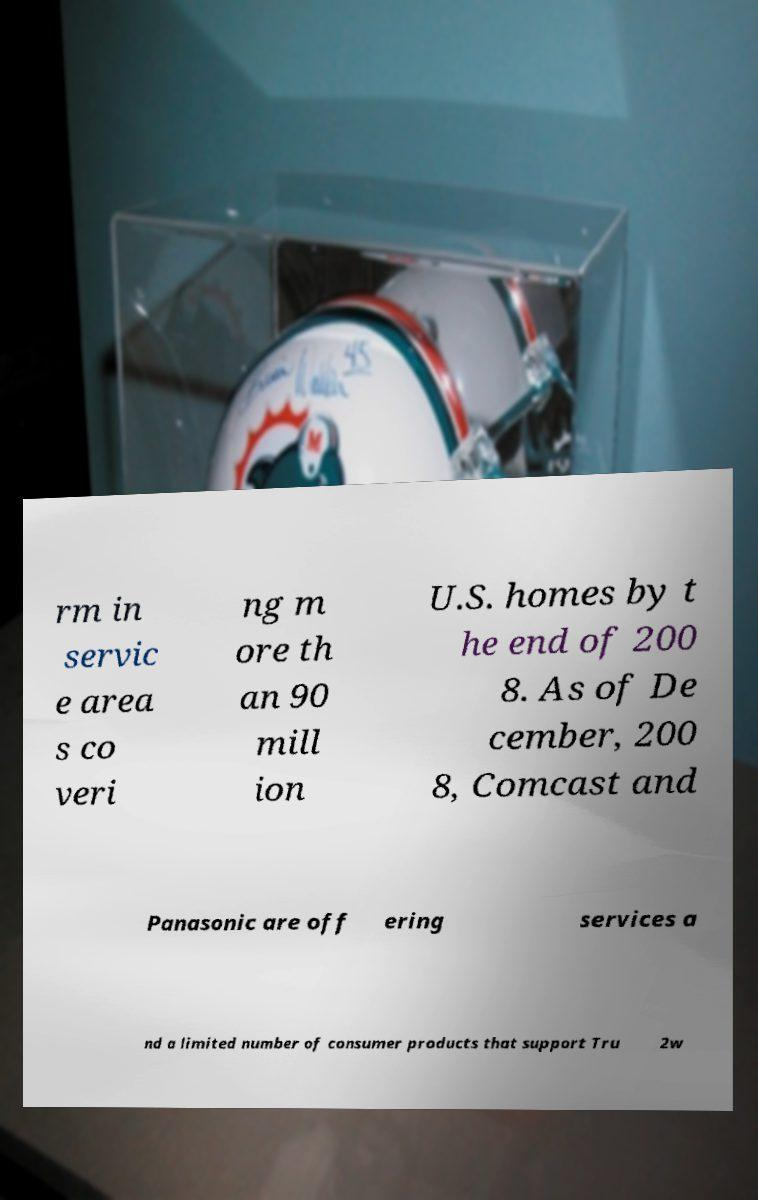Please identify and transcribe the text found in this image. rm in servic e area s co veri ng m ore th an 90 mill ion U.S. homes by t he end of 200 8. As of De cember, 200 8, Comcast and Panasonic are off ering services a nd a limited number of consumer products that support Tru 2w 